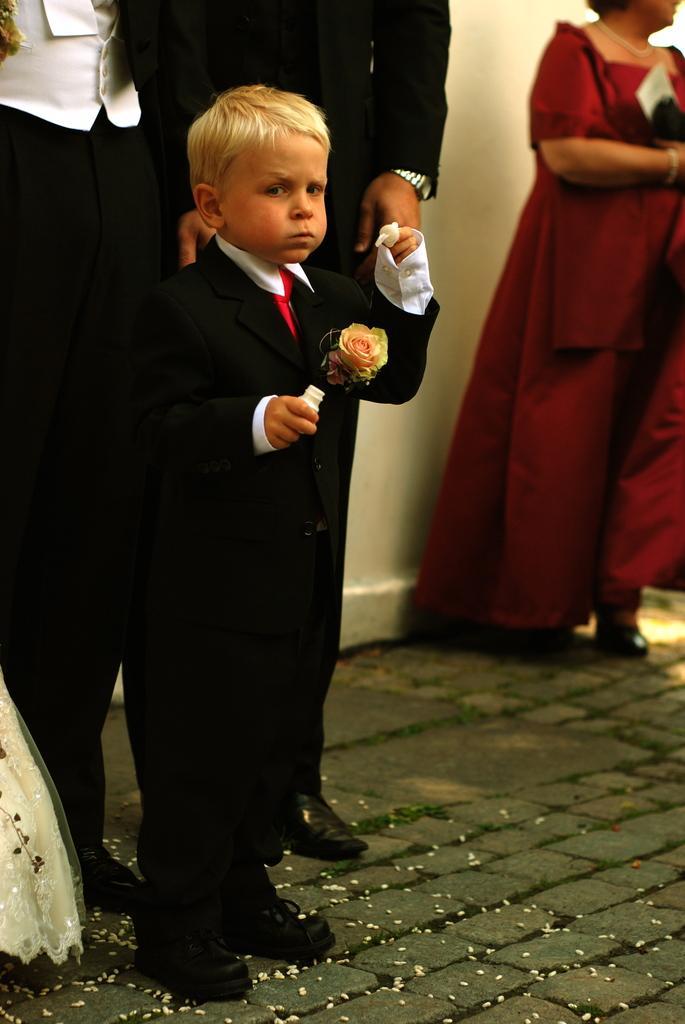Please provide a concise description of this image. In the center of the image, we can see a kid wearing a coat with flower and holding some objects. In the background, there are some other people standing and we can see a wall. At the bottom, there is road. 